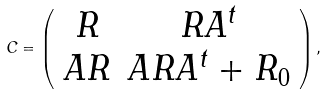<formula> <loc_0><loc_0><loc_500><loc_500>C = \left ( \begin{array} { c c } R & R A ^ { t } \\ A R & A R A ^ { t } + R _ { 0 } \end{array} \right ) ,</formula> 